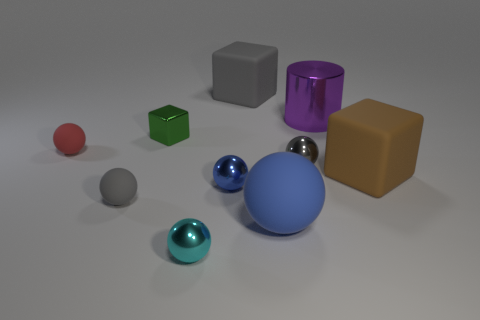Subtract 2 balls. How many balls are left? 4 Subtract all small gray metallic balls. How many balls are left? 5 Subtract all cyan balls. How many balls are left? 5 Subtract all gray cylinders. Subtract all green balls. How many cylinders are left? 1 Subtract all cylinders. How many objects are left? 9 Add 7 metallic cylinders. How many metallic cylinders exist? 8 Subtract 0 yellow blocks. How many objects are left? 10 Subtract all large brown things. Subtract all big blue things. How many objects are left? 8 Add 8 blue shiny spheres. How many blue shiny spheres are left? 9 